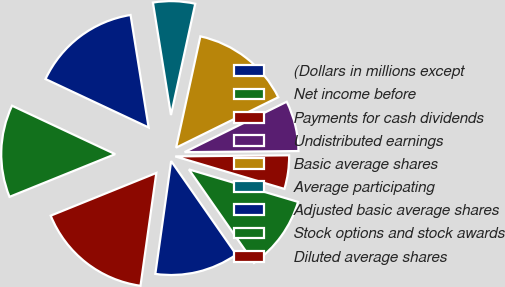Convert chart. <chart><loc_0><loc_0><loc_500><loc_500><pie_chart><fcel>(Dollars in millions except<fcel>Net income before<fcel>Payments for cash dividends<fcel>Undistributed earnings<fcel>Basic average shares<fcel>Average participating<fcel>Adjusted basic average shares<fcel>Stock options and stock awards<fcel>Diluted average shares<nl><fcel>11.9%<fcel>10.71%<fcel>4.76%<fcel>7.14%<fcel>14.29%<fcel>5.95%<fcel>15.48%<fcel>13.1%<fcel>16.67%<nl></chart> 